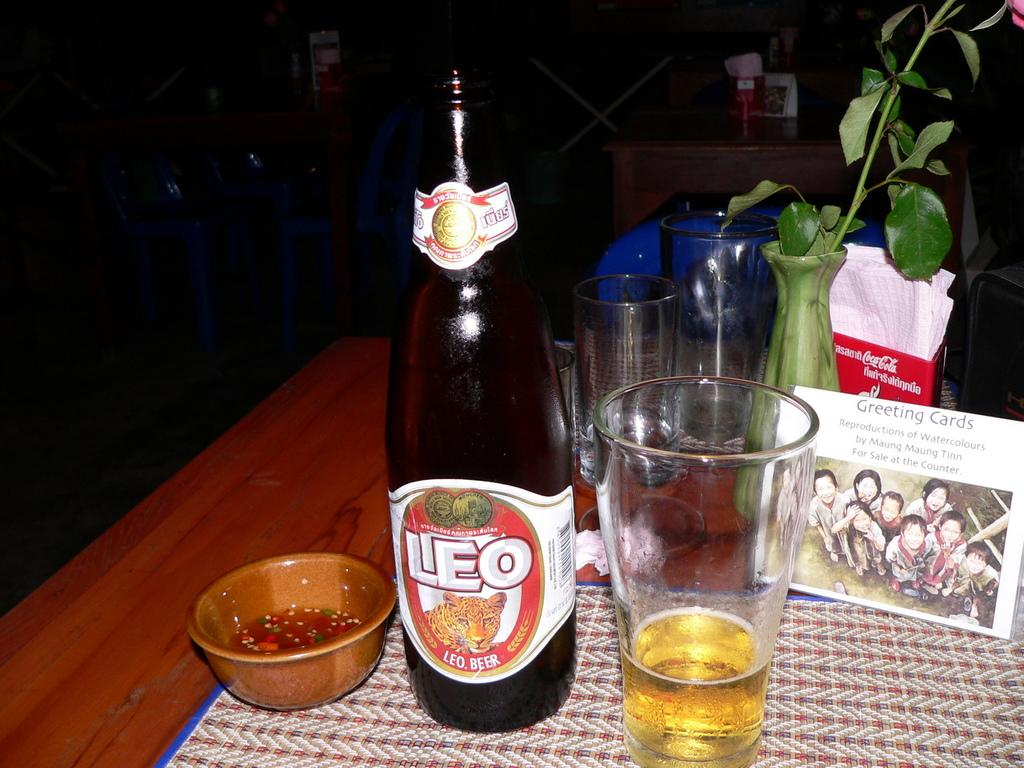<image>
Offer a succinct explanation of the picture presented. A bottle of Leo beer, a glass of beer and a bowl with something red in it. 